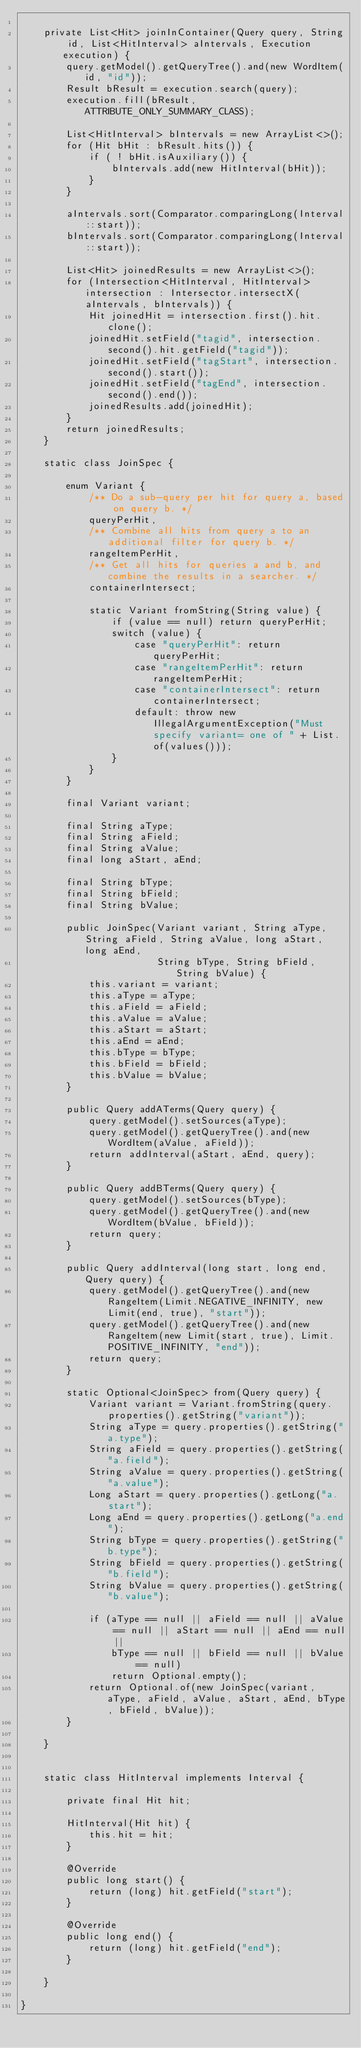<code> <loc_0><loc_0><loc_500><loc_500><_Java_>
    private List<Hit> joinInContainer(Query query, String id, List<HitInterval> aIntervals, Execution execution) {
        query.getModel().getQueryTree().and(new WordItem(id, "id"));
        Result bResult = execution.search(query);
        execution.fill(bResult, ATTRIBUTE_ONLY_SUMMARY_CLASS);

        List<HitInterval> bIntervals = new ArrayList<>();
        for (Hit bHit : bResult.hits()) {
            if ( ! bHit.isAuxiliary()) {
                bIntervals.add(new HitInterval(bHit));
            }
        }

        aIntervals.sort(Comparator.comparingLong(Interval::start));
        bIntervals.sort(Comparator.comparingLong(Interval::start));

        List<Hit> joinedResults = new ArrayList<>();
        for (Intersection<HitInterval, HitInterval> intersection : Intersector.intersectX(aIntervals, bIntervals)) {
            Hit joinedHit = intersection.first().hit.clone();
            joinedHit.setField("tagid", intersection.second().hit.getField("tagid"));
            joinedHit.setField("tagStart", intersection.second().start());
            joinedHit.setField("tagEnd", intersection.second().end());
            joinedResults.add(joinedHit);
        }
        return joinedResults;
    }

    static class JoinSpec {

        enum Variant {
            /** Do a sub-query per hit for query a, based on query b. */
            queryPerHit,
            /** Combine all hits from query a to an additional filter for query b. */
            rangeItemPerHit,
            /** Get all hits for queries a and b, and combine the results in a searcher. */
            containerIntersect;

            static Variant fromString(String value) {
                if (value == null) return queryPerHit;
                switch (value) {
                    case "queryPerHit": return queryPerHit;
                    case "rangeItemPerHit": return rangeItemPerHit;
                    case "containerIntersect": return containerIntersect;
                    default: throw new IllegalArgumentException("Must specify variant= one of " + List.of(values()));
                }
            }
        }

        final Variant variant;

        final String aType;
        final String aField;
        final String aValue;
        final long aStart, aEnd;

        final String bType;
        final String bField;
        final String bValue;

        public JoinSpec(Variant variant, String aType, String aField, String aValue, long aStart, long aEnd,
                        String bType, String bField, String bValue) {
            this.variant = variant;
            this.aType = aType;
            this.aField = aField;
            this.aValue = aValue;
            this.aStart = aStart;
            this.aEnd = aEnd;
            this.bType = bType;
            this.bField = bField;
            this.bValue = bValue;
        }

        public Query addATerms(Query query) {
            query.getModel().setSources(aType);
            query.getModel().getQueryTree().and(new WordItem(aValue, aField));
            return addInterval(aStart, aEnd, query);
        }

        public Query addBTerms(Query query) {
            query.getModel().setSources(bType);
            query.getModel().getQueryTree().and(new WordItem(bValue, bField));
            return query;
        }

        public Query addInterval(long start, long end, Query query) {
            query.getModel().getQueryTree().and(new RangeItem(Limit.NEGATIVE_INFINITY, new Limit(end, true), "start"));
            query.getModel().getQueryTree().and(new RangeItem(new Limit(start, true), Limit.POSITIVE_INFINITY, "end"));
            return query;
        }

        static Optional<JoinSpec> from(Query query) {
            Variant variant = Variant.fromString(query.properties().getString("variant"));
            String aType = query.properties().getString("a.type");
            String aField = query.properties().getString("a.field");
            String aValue = query.properties().getString("a.value");
            Long aStart = query.properties().getLong("a.start");
            Long aEnd = query.properties().getLong("a.end");
            String bType = query.properties().getString("b.type");
            String bField = query.properties().getString("b.field");
            String bValue = query.properties().getString("b.value");

            if (aType == null || aField == null || aValue == null || aStart == null || aEnd == null ||
                bType == null || bField == null || bValue == null)
                return Optional.empty();
            return Optional.of(new JoinSpec(variant, aType, aField, aValue, aStart, aEnd, bType, bField, bValue));
        }

    }


    static class HitInterval implements Interval {

        private final Hit hit;

        HitInterval(Hit hit) {
            this.hit = hit;
        }

        @Override
        public long start() {
            return (long) hit.getField("start");
        }

        @Override
        public long end() {
            return (long) hit.getField("end");
        }

    }

}
</code> 